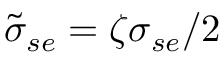Convert formula to latex. <formula><loc_0><loc_0><loc_500><loc_500>\tilde { \sigma } _ { s e } = \zeta \sigma _ { s e } / 2</formula> 